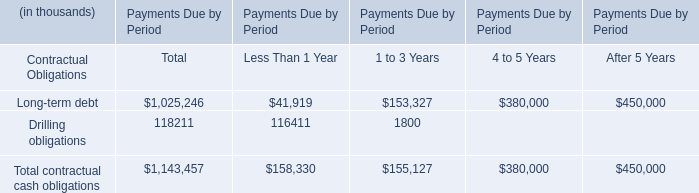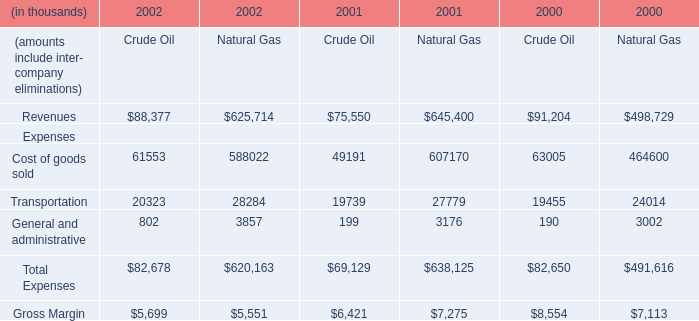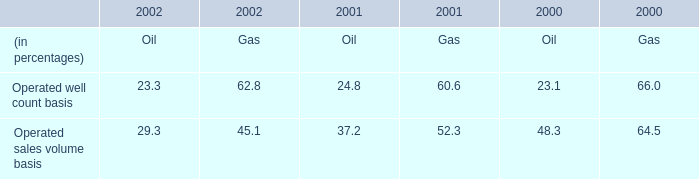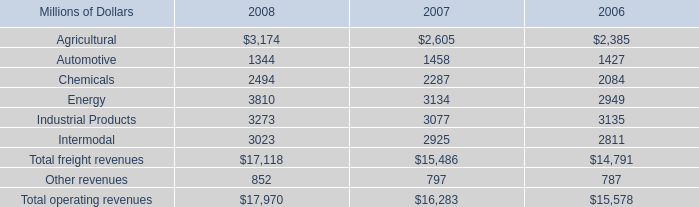Which year does the amounts include inter- company eliminations in terms of Total Expenses for Natural Gas rank first? 
Answer: 2001. 